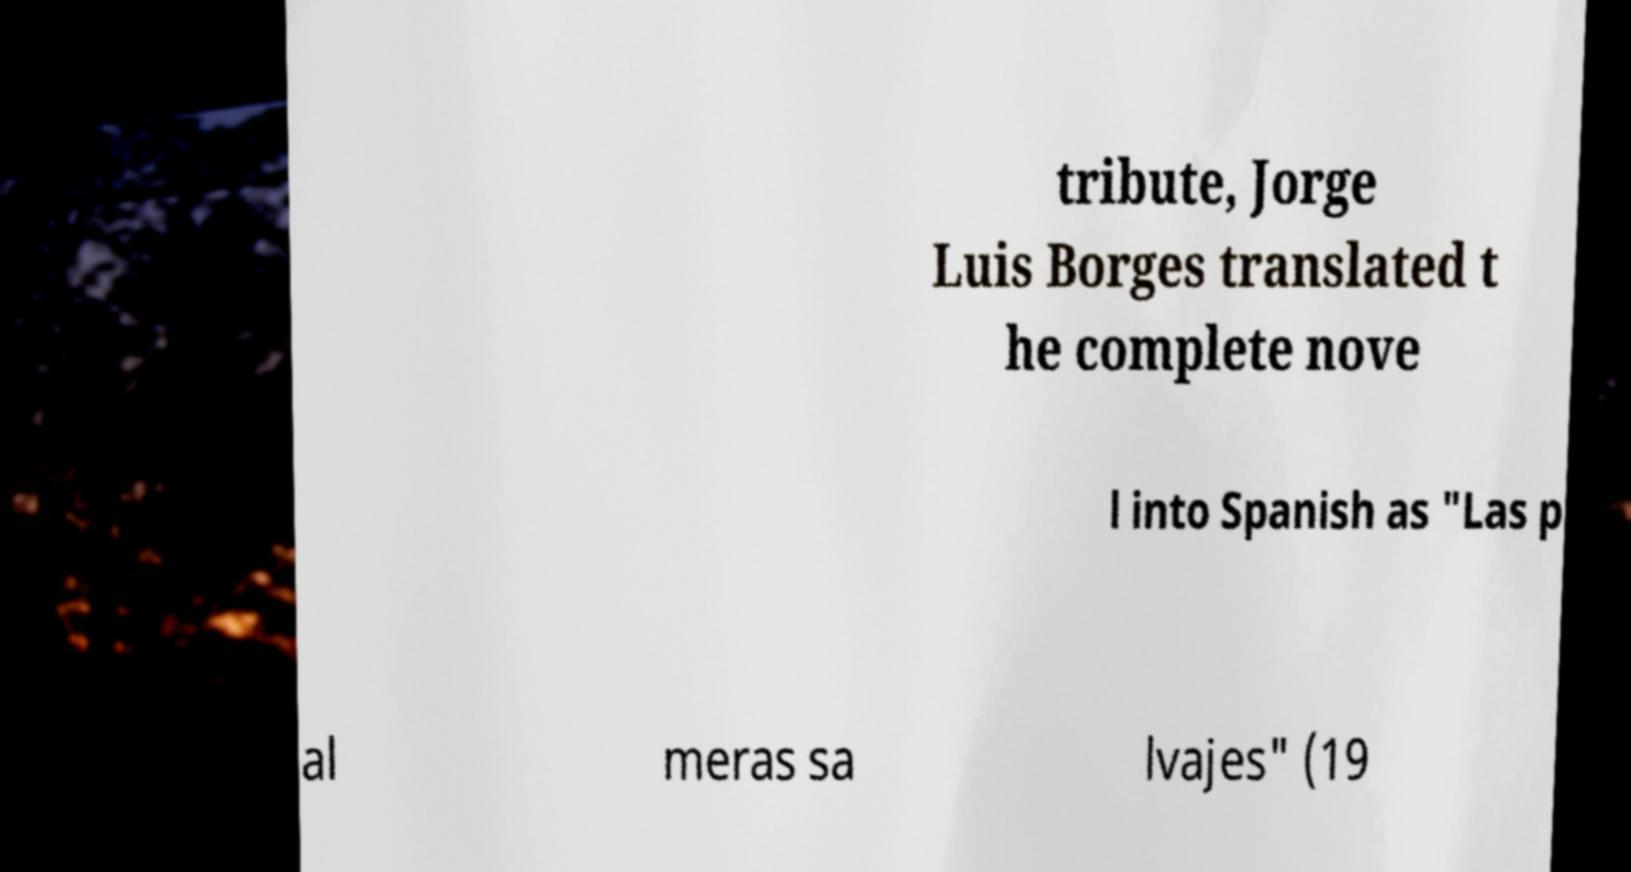Could you extract and type out the text from this image? tribute, Jorge Luis Borges translated t he complete nove l into Spanish as "Las p al meras sa lvajes" (19 